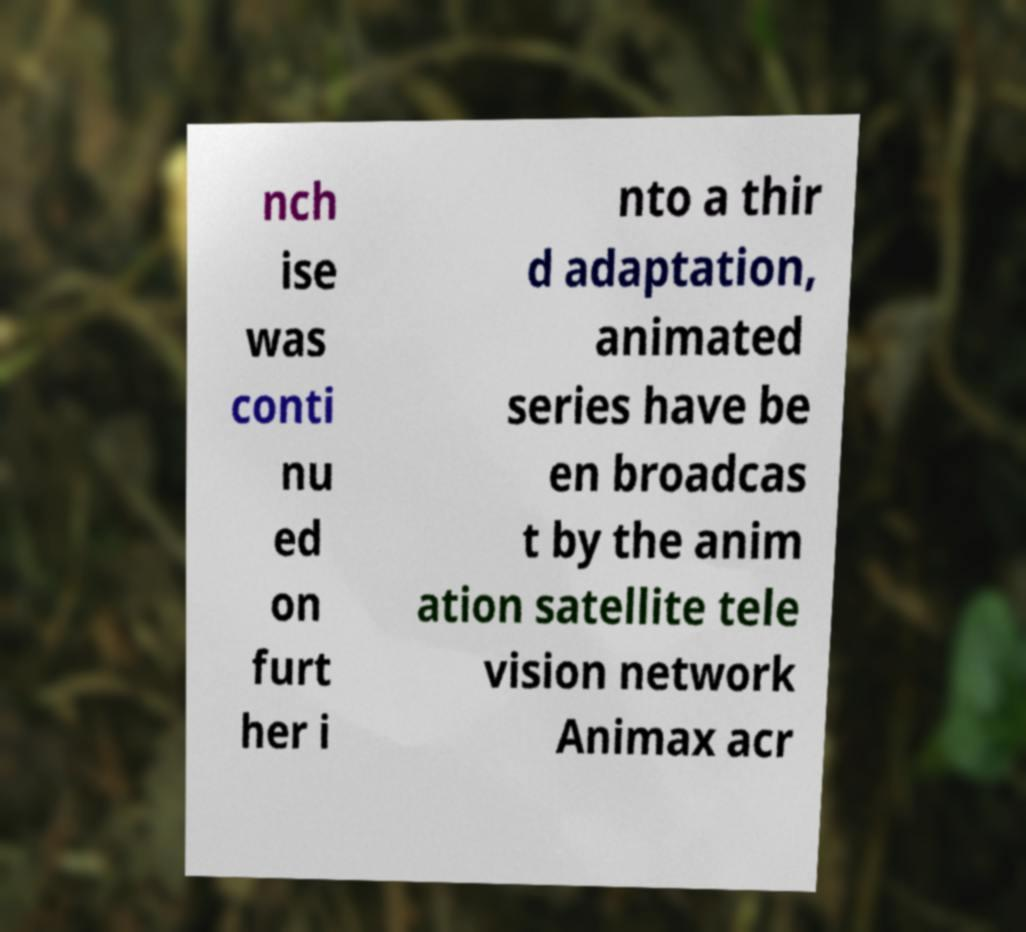There's text embedded in this image that I need extracted. Can you transcribe it verbatim? nch ise was conti nu ed on furt her i nto a thir d adaptation, animated series have be en broadcas t by the anim ation satellite tele vision network Animax acr 